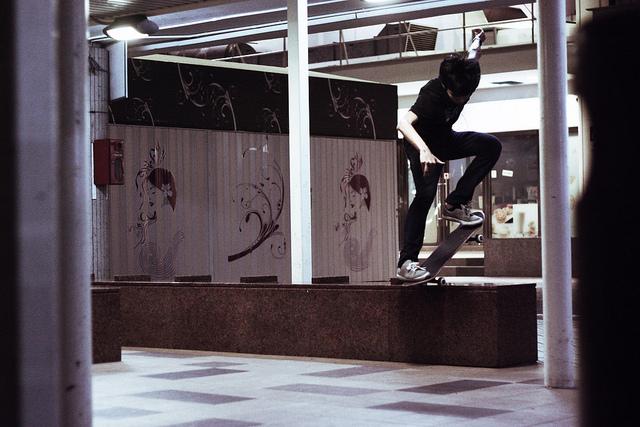What trick is being performed?
Give a very brief answer. Balancing. Is this person indoors?
Write a very short answer. Yes. Is this person balancing on the counter?
Concise answer only. Yes. 